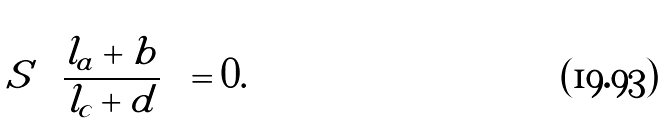Convert formula to latex. <formula><loc_0><loc_0><loc_500><loc_500>S \left ( \frac { l _ { a } + b } { l _ { c } + d } \right ) = 0 .</formula> 